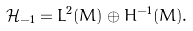Convert formula to latex. <formula><loc_0><loc_0><loc_500><loc_500>\mathcal { H } _ { - 1 } = L ^ { 2 } ( M ) \oplus H ^ { - 1 } ( M ) .</formula> 